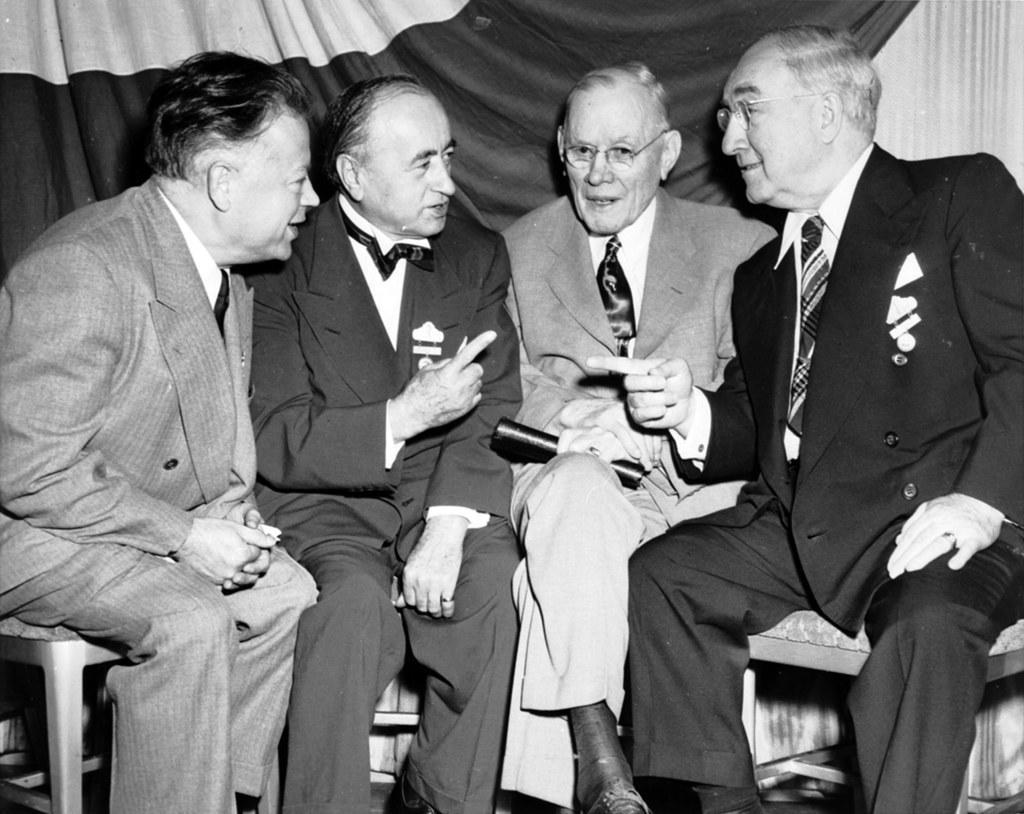In one or two sentences, can you explain what this image depicts? This image is a black and white image. This image is taken indoors. In the background there is a wall and there is a curtain. In the middle of the image four men are sitting on the stools and talking. They have worn suits, ties and shirts. 